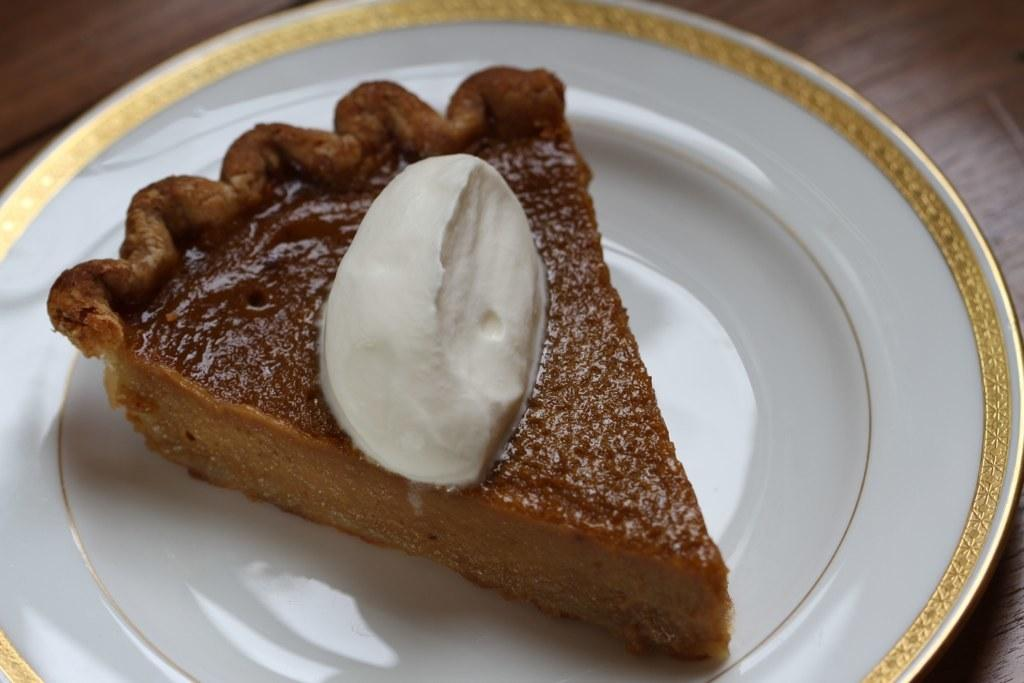What object is present on the plate in the image? The plate contains a cake. What type of food is on the plate? The food on the plate is a cake. What color is the paint on the hand in the image? There is no hand or paint present in the image; it only features a plate with a cake. 